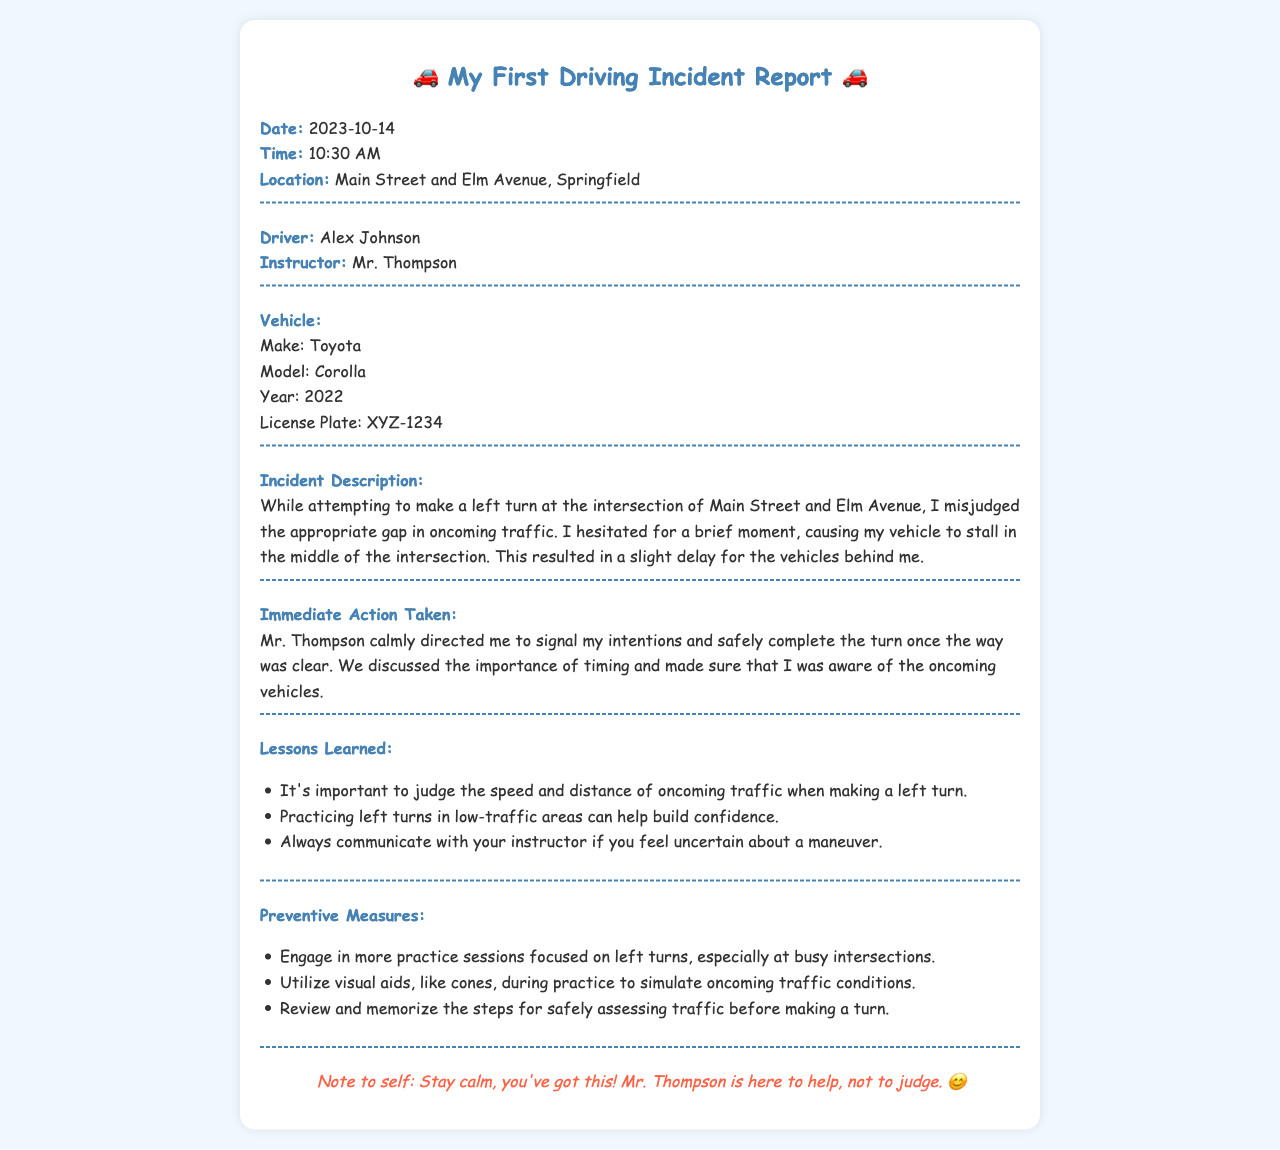what is the date of the incident? The date of the incident is specified in the document as 2023-10-14.
Answer: 2023-10-14 who was the driver involved in the incident? The driver's name is mentioned in the document as Alex Johnson.
Answer: Alex Johnson what vehicle make was used during the incident? The make of the vehicle is provided in the document, which is Toyota.
Answer: Toyota where did the incident occur? The location of the incident is specified in the document as Main Street and Elm Avenue, Springfield.
Answer: Main Street and Elm Avenue, Springfield what immediate action did Mr. Thompson take? The document states that Mr. Thompson directed the driver to signal and safely complete the turn.
Answer: Signal my intentions and safely complete the turn what lesson is emphasized regarding left turns? The document highlights the importance of judging the speed and distance of oncoming traffic for left turns.
Answer: Judge the speed and distance of oncoming traffic how can the driver build confidence when making left turns? Practicing left turns in low-traffic areas is mentioned as a way to build confidence.
Answer: Practicing in low-traffic areas what is one preventive measure suggested? One preventive measure stated in the document is to engage in more practice sessions focused on left turns.
Answer: Engage in more practice sessions who is the instructor mentioned in the report? The report identifies the instructor as Mr. Thompson.
Answer: Mr. Thompson 